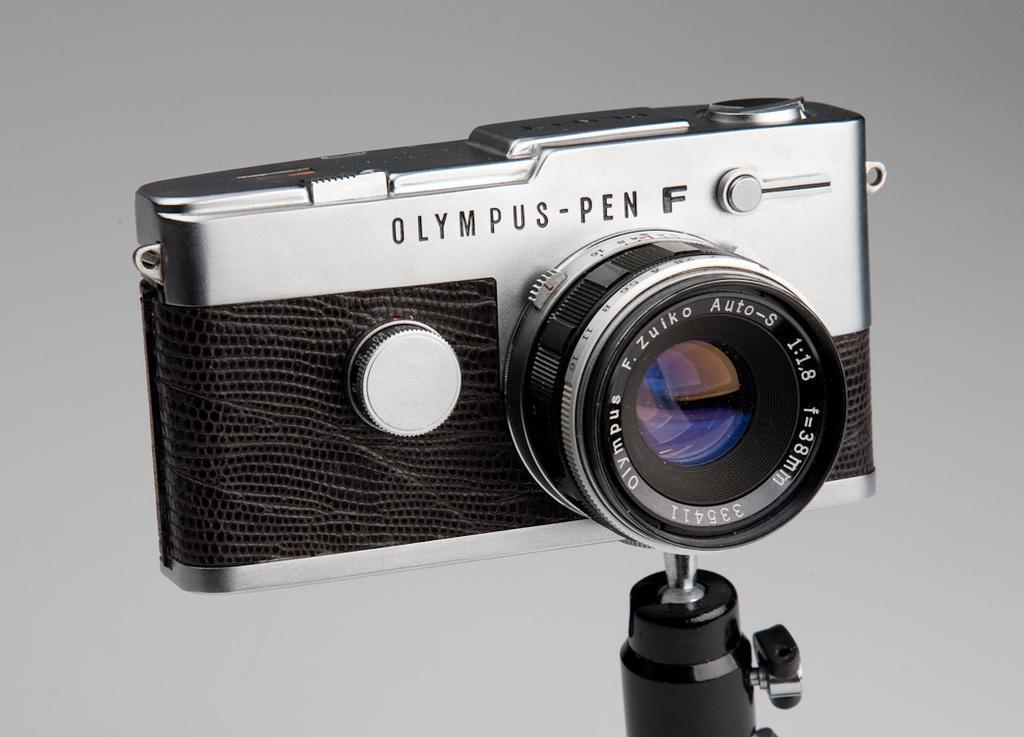Could you give a brief overview of what you see in this image? In the image there is a camera and the background of the camera is in grey color. 